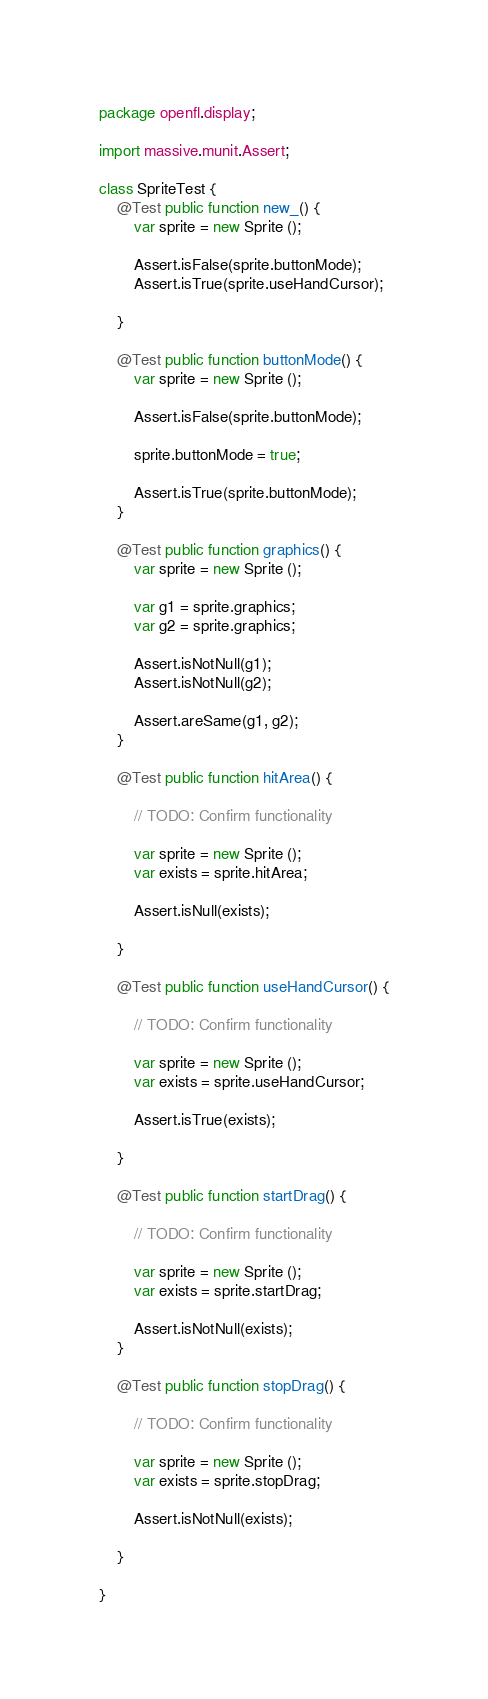<code> <loc_0><loc_0><loc_500><loc_500><_Haxe_>package openfl.display;

import massive.munit.Assert;

class SpriteTest {
	@Test public function new_() {
		var sprite = new Sprite ();

		Assert.isFalse(sprite.buttonMode);
		Assert.isTrue(sprite.useHandCursor);

	}

	@Test public function buttonMode() {
		var sprite = new Sprite ();

		Assert.isFalse(sprite.buttonMode);

		sprite.buttonMode = true;

		Assert.isTrue(sprite.buttonMode);
	}

	@Test public function graphics() {
		var sprite = new Sprite ();

		var g1 = sprite.graphics;
		var g2 = sprite.graphics;

		Assert.isNotNull(g1);
		Assert.isNotNull(g2);

		Assert.areSame(g1, g2);
	}

	@Test public function hitArea() {

		// TODO: Confirm functionality

		var sprite = new Sprite ();
		var exists = sprite.hitArea;

		Assert.isNull(exists);

	}

	@Test public function useHandCursor() {

		// TODO: Confirm functionality

		var sprite = new Sprite ();
		var exists = sprite.useHandCursor;

		Assert.isTrue(exists);

	}

	@Test public function startDrag() {

		// TODO: Confirm functionality
		
		var sprite = new Sprite ();
		var exists = sprite.startDrag;

		Assert.isNotNull(exists);
	}

	@Test public function stopDrag() {

		// TODO: Confirm functionality

		var sprite = new Sprite ();
		var exists = sprite.stopDrag;

		Assert.isNotNull(exists);

	}

}</code> 